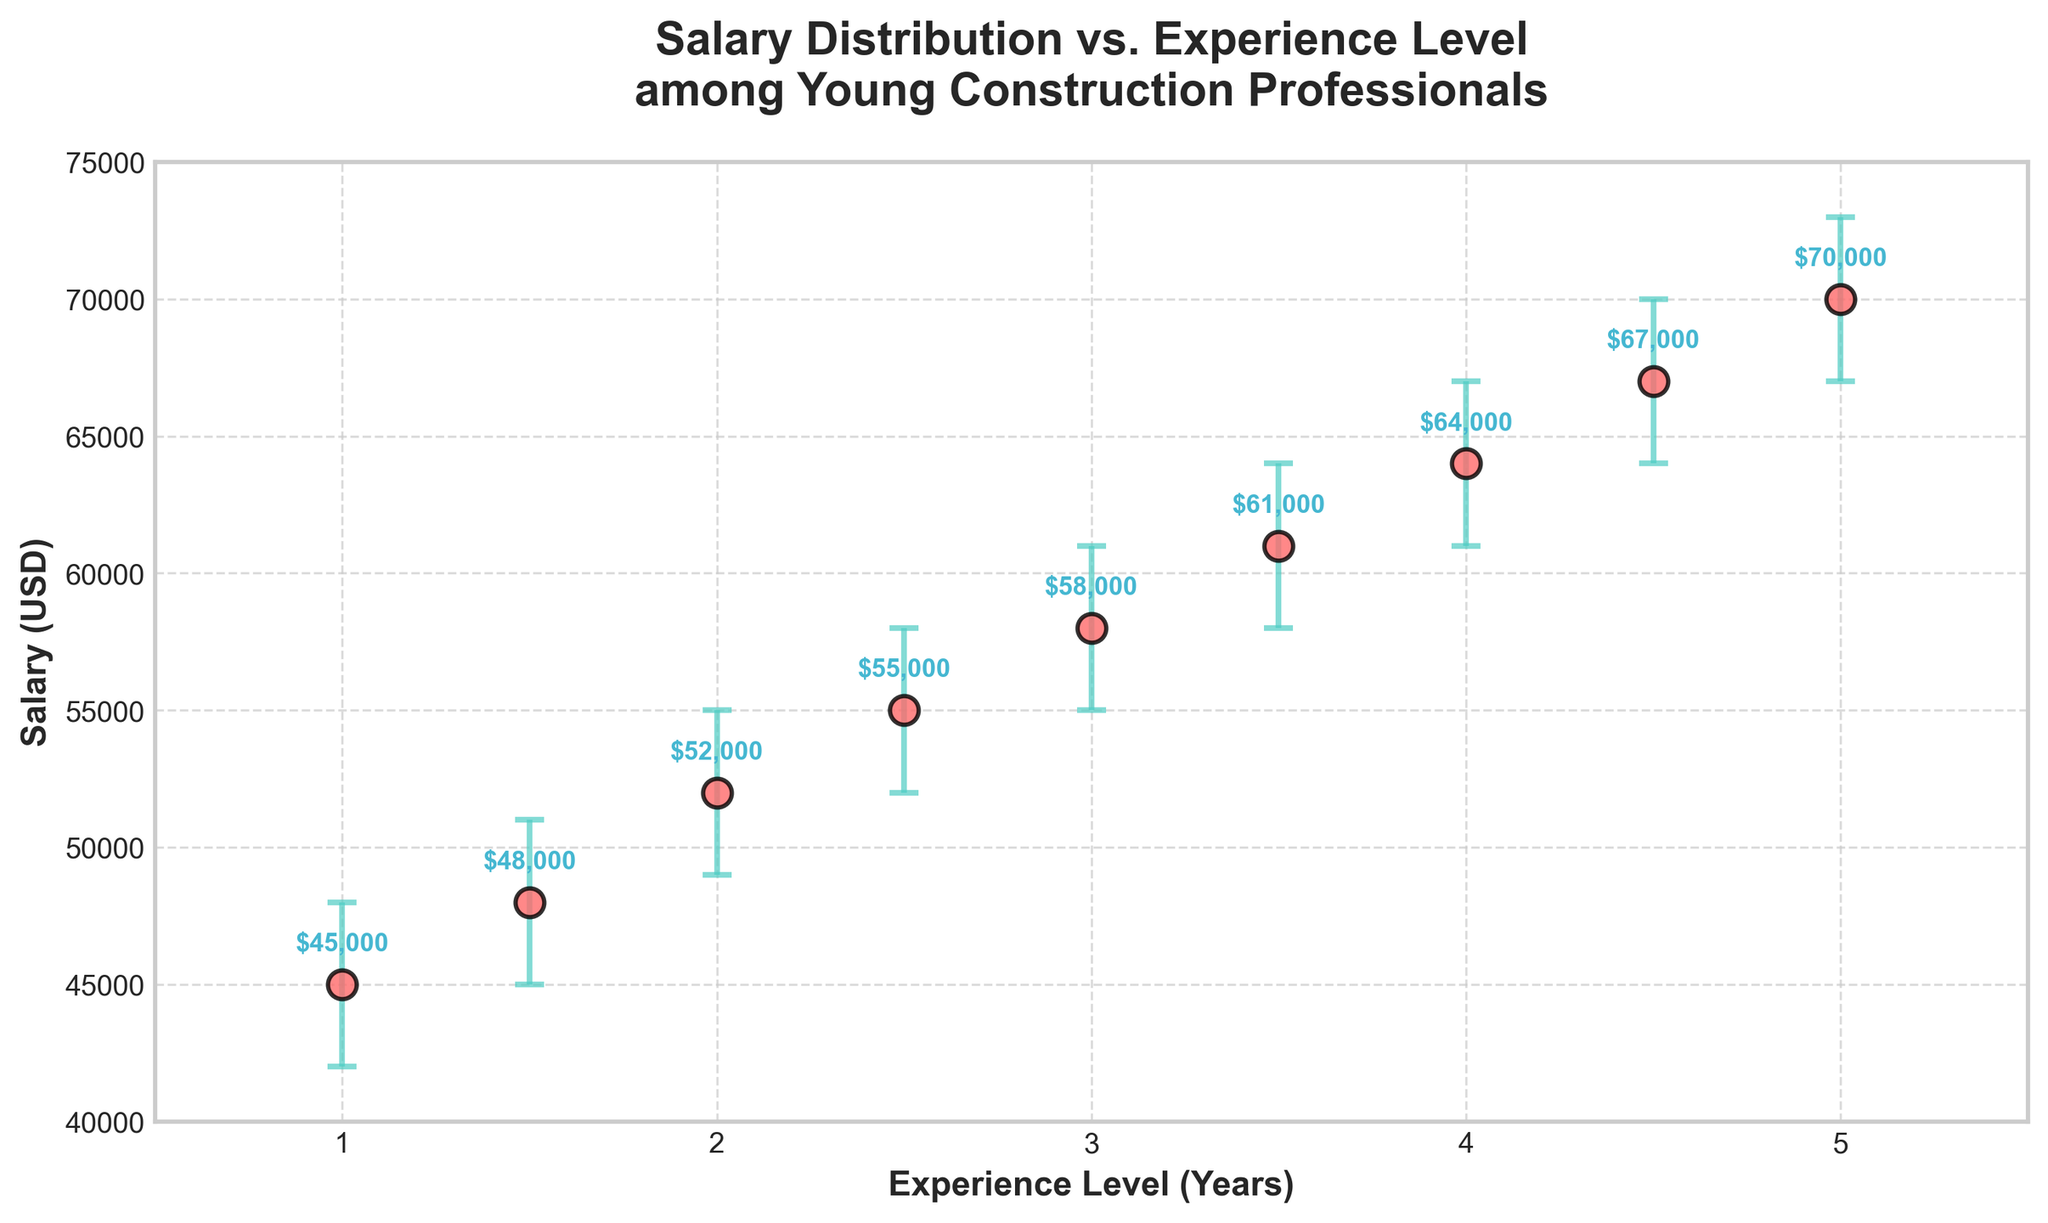what is the title of the figure? The title is usually displayed at the top of the figure. It provides a summary of what the figure represents.
Answer: Salary Distribution vs. Experience Level among Young Construction Professionals what are the labels on the x and y axes? The x-axis label represents the horizontal data (Experience Level) and the y-axis label represents the vertical data (Salary). These labels help to understand what each axis in the graph represents.
Answer: Experience Level (Years) and Salary (USD) how many data points are shown in the figure? Data points are represented by scatter points in the figure. Simply count the number of scatter points to determine the total number of data points.
Answer: 9 which experience level has the highest salary? The scatter point with the highest placement on the y-axis indicates the highest salary. Examine the y-values to find the highest salary and note the corresponding x-value.
Answer: 5 Years what is the confidence interval for the salary of professionals with 2.5 years of experience? The confidence interval is shown by the error bars extending above and below the scatter points. Look at the error bars and annotate the corresponding y-values for the experience level of 2.5 years.
Answer: $52,000 to $58,000 what is the salary difference between professionals with 1 year of experience and 3 years of experience? Subtract the salary at 1 year of experience from the salary at 3 years of experience.
Answer: $13,000 which experience level has the largest error bar? The error bars show the range of the confidence interval. The experience level with the longest vertical error bar has the largest error range. Compare the lengths of all error bars to determine this.
Answer: 5 Years does the salary increase consistently with increased experience levels? Visually inspect the scatter plot to see if the scatter points form a consistent upward trend. This would indicate that salary generally increases as experience level increases.
Answer: Yes what is the salary range for professionals with 3.5 years of experience? The salary range is given by the error bars. Identify the lower and upper bounds of the error bar for professionals with 3.5 years of experience.
Answer: $58,000 to $64,000 